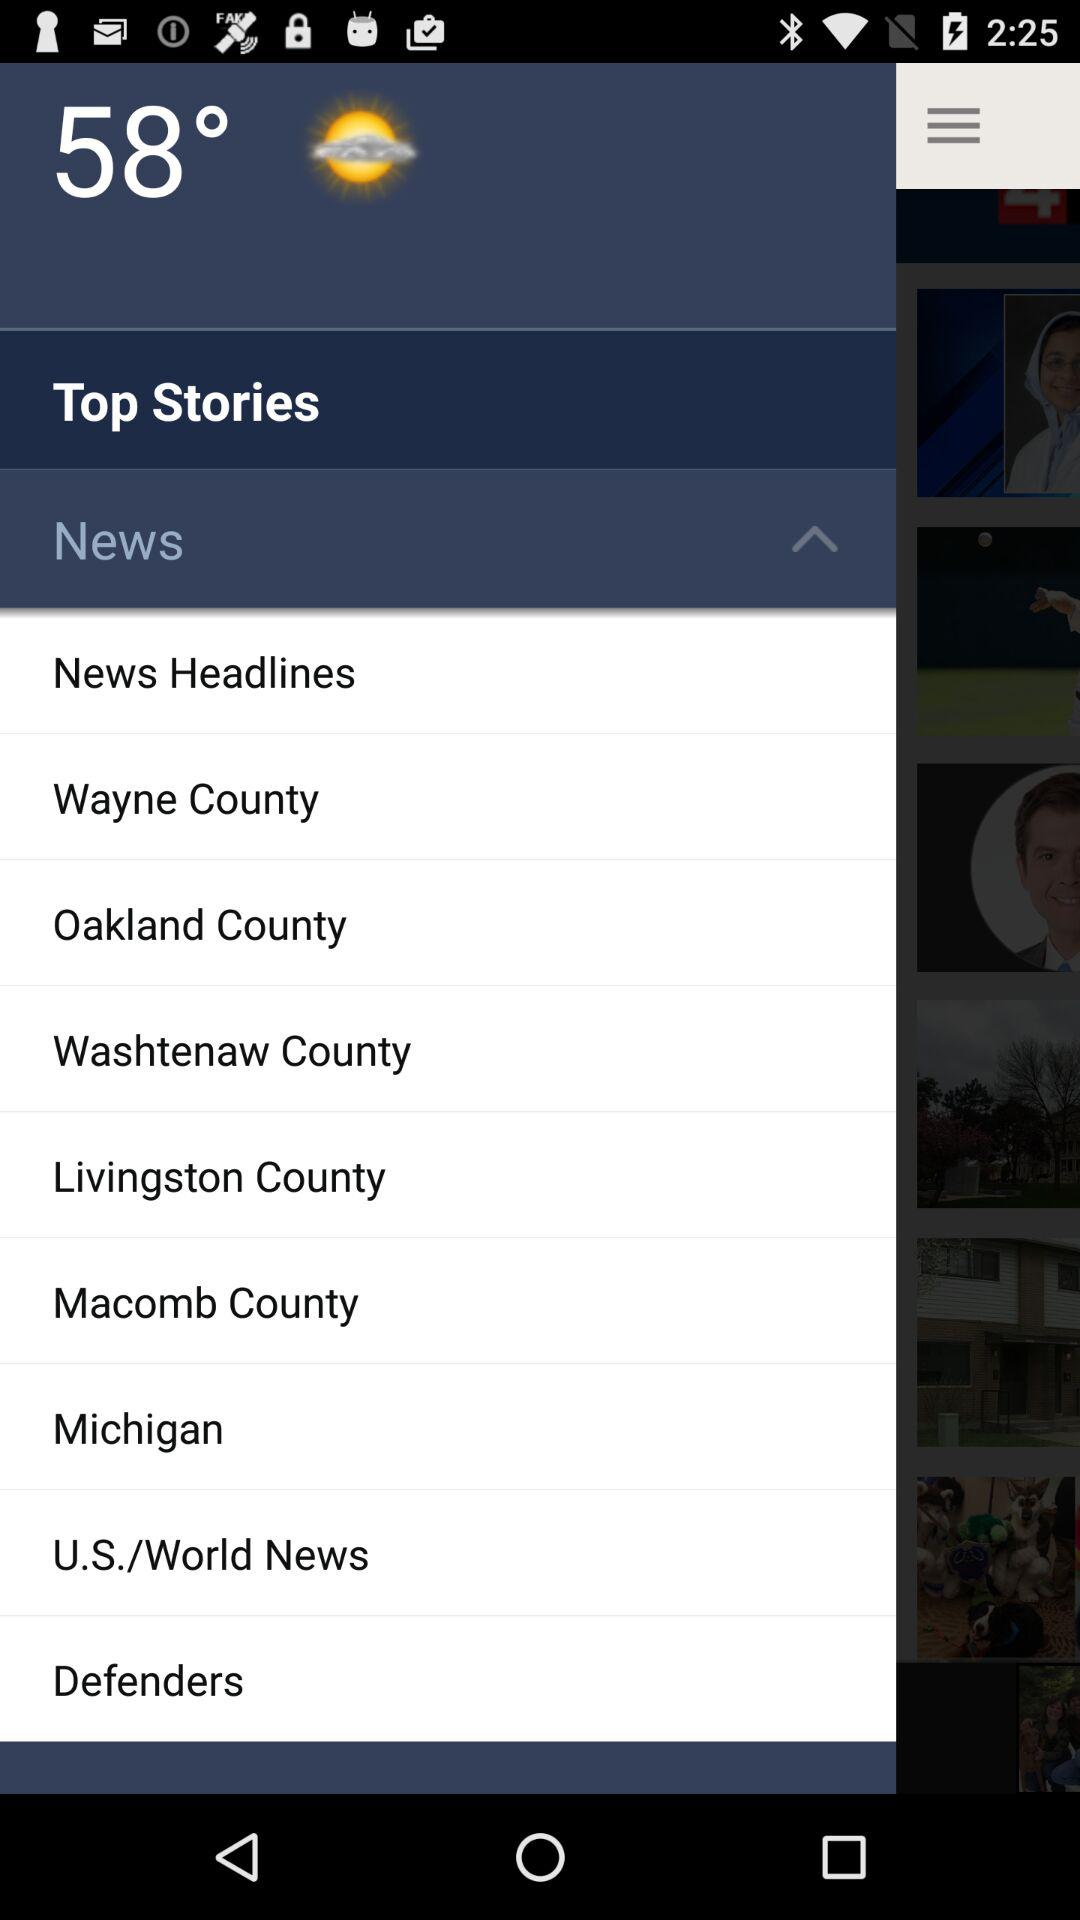What is the weather forecast? The weather is partly cloudy. 